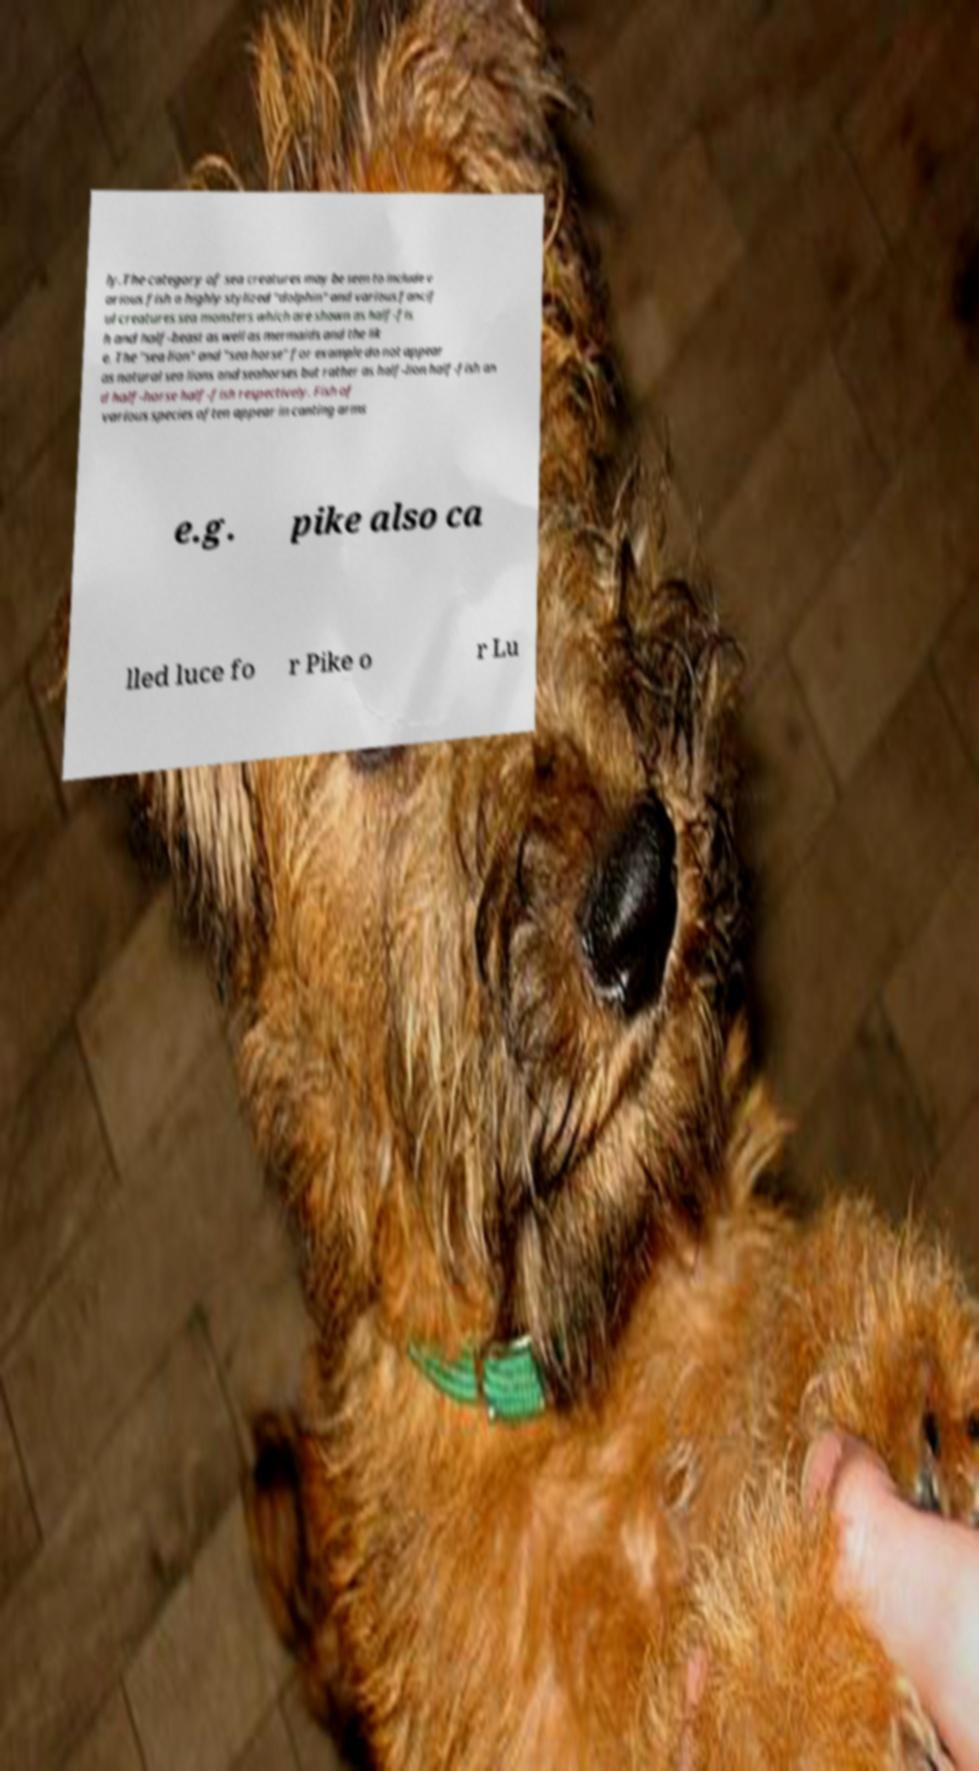Could you extract and type out the text from this image? ly.The category of sea creatures may be seen to include v arious fish a highly stylized "dolphin" and various fancif ul creatures sea monsters which are shown as half-fis h and half-beast as well as mermaids and the lik e. The "sea lion" and "sea horse" for example do not appear as natural sea lions and seahorses but rather as half-lion half-fish an d half-horse half-fish respectively. Fish of various species often appear in canting arms e.g. pike also ca lled luce fo r Pike o r Lu 